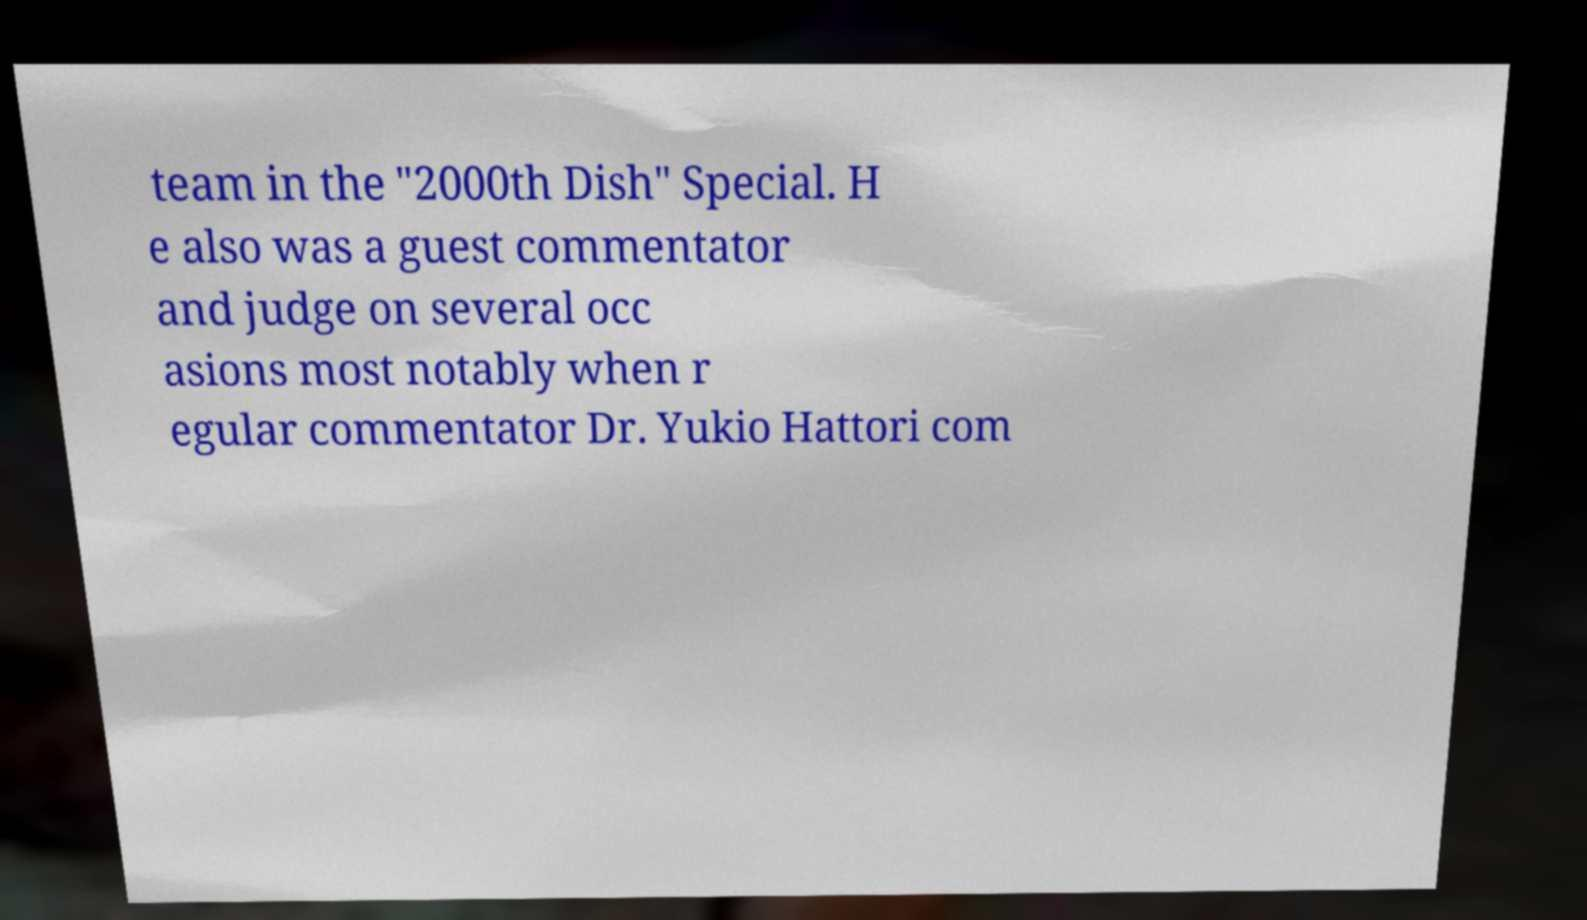For documentation purposes, I need the text within this image transcribed. Could you provide that? team in the "2000th Dish" Special. H e also was a guest commentator and judge on several occ asions most notably when r egular commentator Dr. Yukio Hattori com 